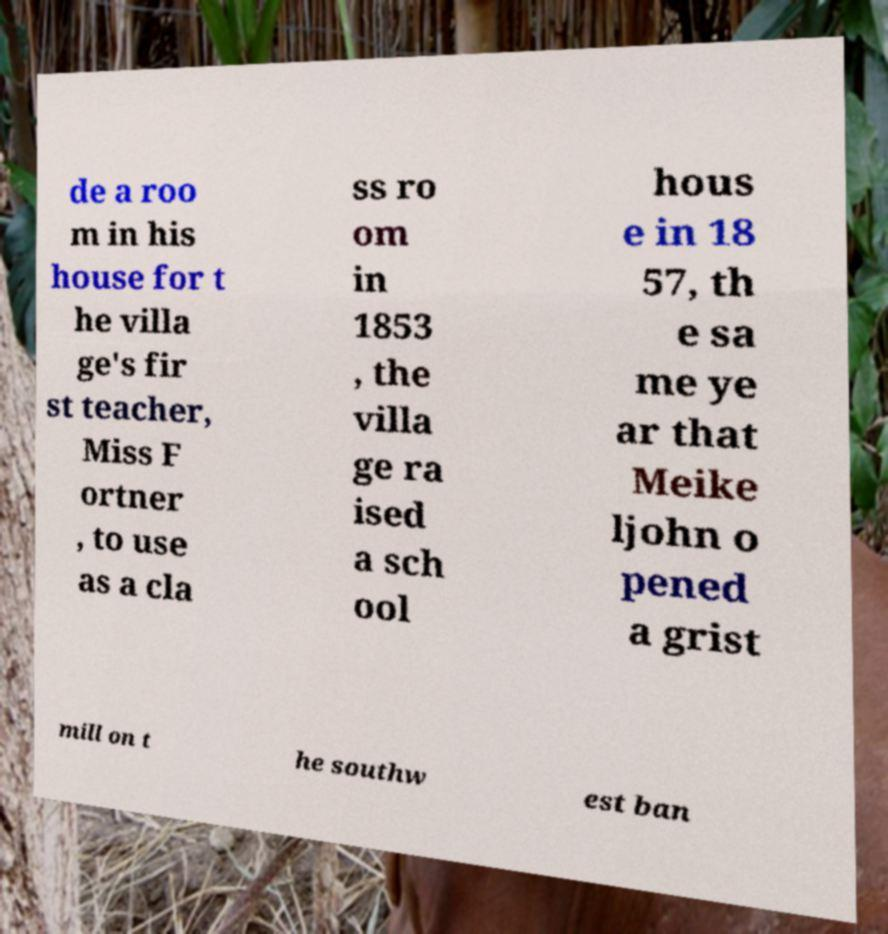Please read and relay the text visible in this image. What does it say? de a roo m in his house for t he villa ge's fir st teacher, Miss F ortner , to use as a cla ss ro om in 1853 , the villa ge ra ised a sch ool hous e in 18 57, th e sa me ye ar that Meike ljohn o pened a grist mill on t he southw est ban 